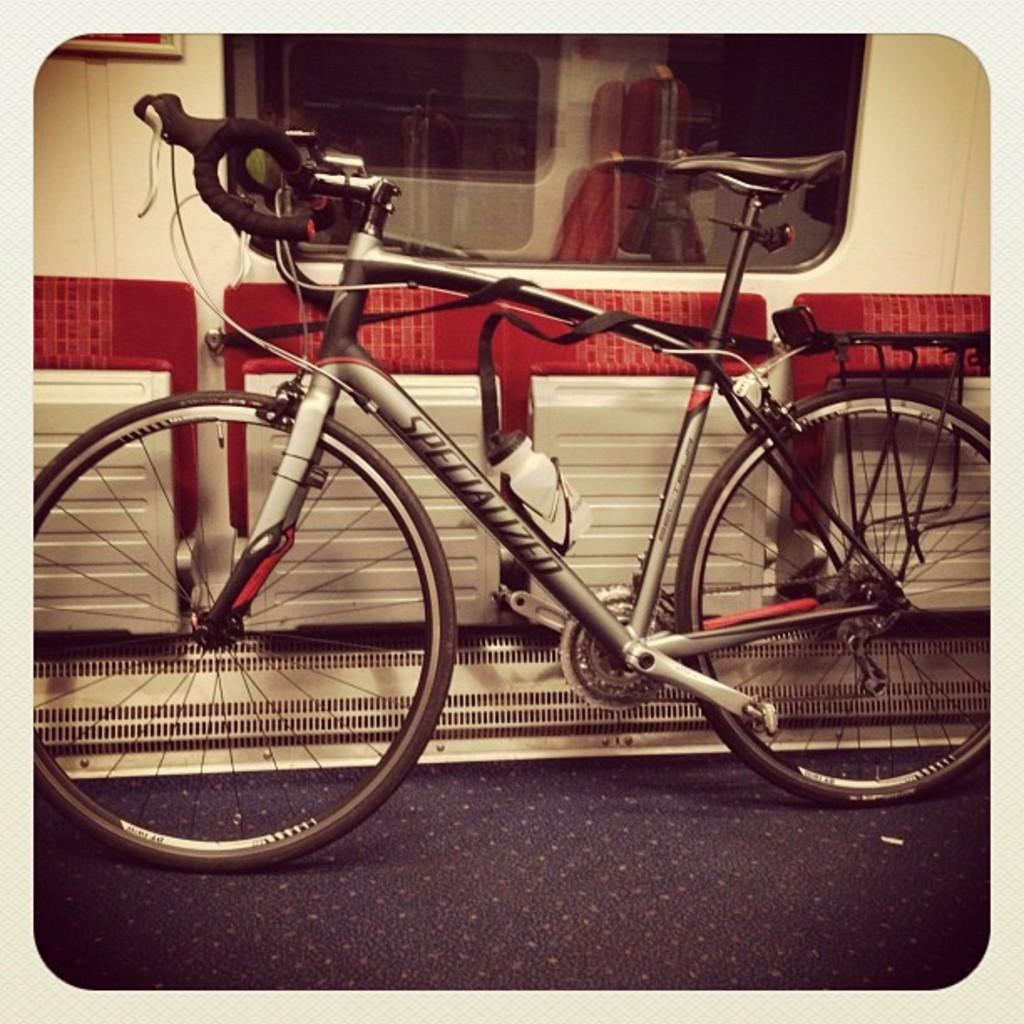Please provide a concise description of this image. In this picture I can see there is a bicycle and it has a frame, paddles, wheels, saddle, handle and there is a glass window in the backdrop. 